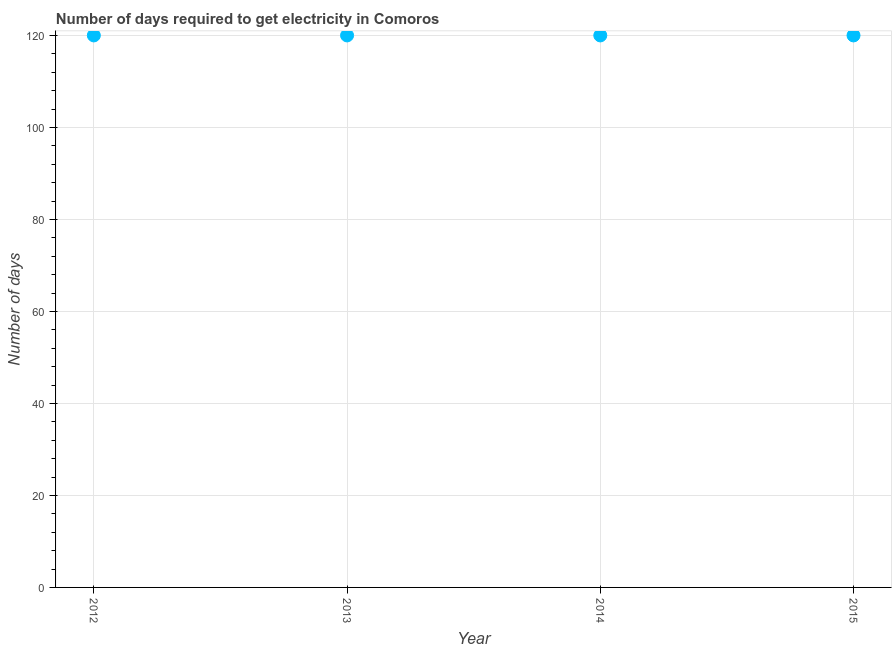What is the time to get electricity in 2014?
Provide a succinct answer. 120. Across all years, what is the maximum time to get electricity?
Ensure brevity in your answer.  120. Across all years, what is the minimum time to get electricity?
Your response must be concise. 120. What is the sum of the time to get electricity?
Give a very brief answer. 480. What is the difference between the time to get electricity in 2014 and 2015?
Make the answer very short. 0. What is the average time to get electricity per year?
Your answer should be very brief. 120. What is the median time to get electricity?
Ensure brevity in your answer.  120. In how many years, is the time to get electricity greater than 100 ?
Provide a succinct answer. 4. Is the time to get electricity in 2013 less than that in 2015?
Ensure brevity in your answer.  No. Is the difference between the time to get electricity in 2012 and 2015 greater than the difference between any two years?
Offer a very short reply. Yes. Is the sum of the time to get electricity in 2012 and 2015 greater than the maximum time to get electricity across all years?
Your answer should be very brief. Yes. What is the difference between the highest and the lowest time to get electricity?
Provide a short and direct response. 0. Does the time to get electricity monotonically increase over the years?
Provide a short and direct response. No. How many years are there in the graph?
Provide a short and direct response. 4. What is the difference between two consecutive major ticks on the Y-axis?
Your answer should be compact. 20. Are the values on the major ticks of Y-axis written in scientific E-notation?
Offer a very short reply. No. What is the title of the graph?
Your answer should be compact. Number of days required to get electricity in Comoros. What is the label or title of the Y-axis?
Your answer should be compact. Number of days. What is the Number of days in 2012?
Give a very brief answer. 120. What is the Number of days in 2013?
Ensure brevity in your answer.  120. What is the Number of days in 2014?
Give a very brief answer. 120. What is the Number of days in 2015?
Offer a terse response. 120. What is the difference between the Number of days in 2012 and 2013?
Your response must be concise. 0. What is the ratio of the Number of days in 2012 to that in 2013?
Provide a succinct answer. 1. What is the ratio of the Number of days in 2012 to that in 2015?
Provide a succinct answer. 1. What is the ratio of the Number of days in 2013 to that in 2014?
Your answer should be compact. 1. What is the ratio of the Number of days in 2013 to that in 2015?
Offer a very short reply. 1. What is the ratio of the Number of days in 2014 to that in 2015?
Offer a very short reply. 1. 